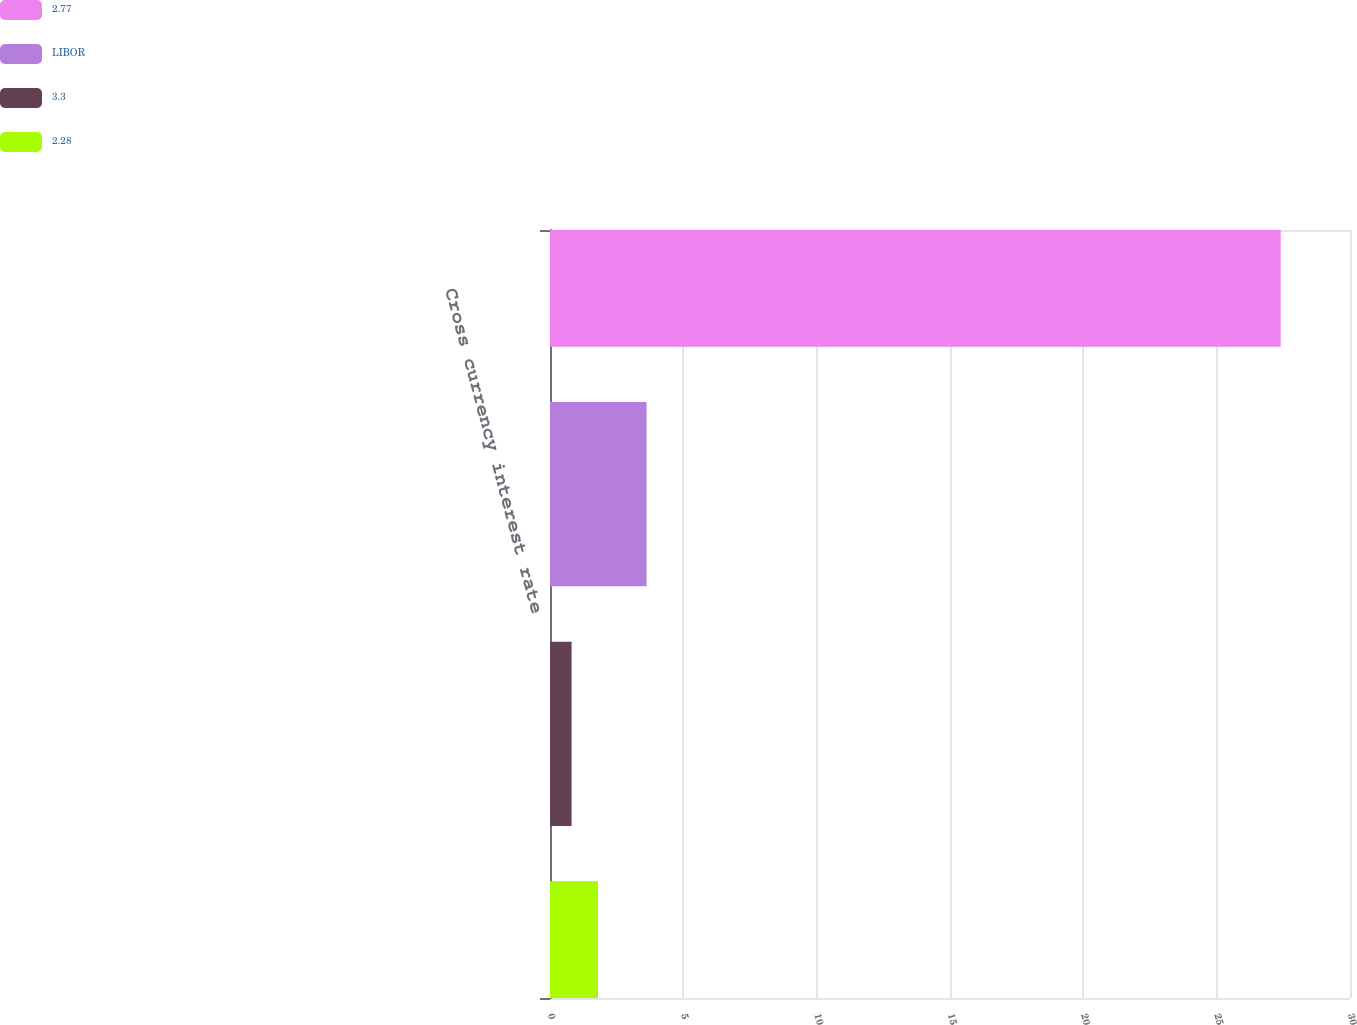Convert chart. <chart><loc_0><loc_0><loc_500><loc_500><stacked_bar_chart><ecel><fcel>Cross currency interest rate<nl><fcel>2.77<fcel>27.4<nl><fcel>LIBOR<fcel>3.62<nl><fcel>3.3<fcel>0.81<nl><fcel>2.28<fcel>1.8<nl></chart> 